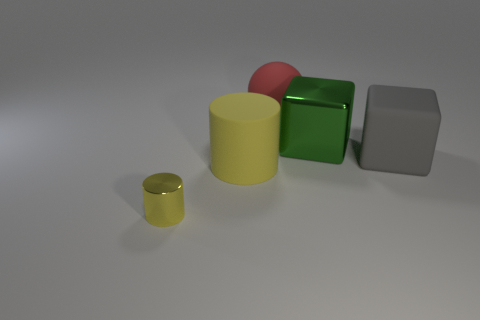Add 3 big gray objects. How many objects exist? 8 Subtract 1 cylinders. How many cylinders are left? 1 Add 2 small gray cubes. How many small gray cubes exist? 2 Subtract 0 purple blocks. How many objects are left? 5 Subtract all cylinders. How many objects are left? 3 Subtract all gray cylinders. Subtract all green blocks. How many cylinders are left? 2 Subtract all brown spheres. How many purple cylinders are left? 0 Subtract all cylinders. Subtract all balls. How many objects are left? 2 Add 1 yellow objects. How many yellow objects are left? 3 